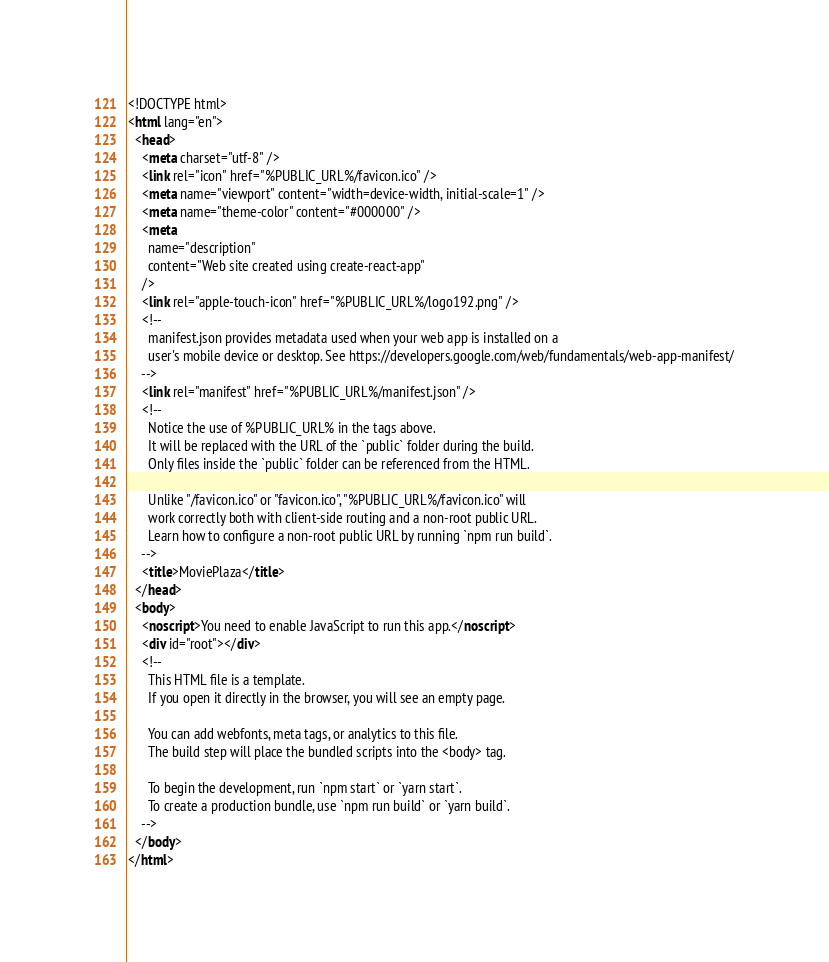<code> <loc_0><loc_0><loc_500><loc_500><_HTML_><!DOCTYPE html>
<html lang="en">
  <head>
    <meta charset="utf-8" />
    <link rel="icon" href="%PUBLIC_URL%/favicon.ico" />
    <meta name="viewport" content="width=device-width, initial-scale=1" />
    <meta name="theme-color" content="#000000" />
    <meta
      name="description"
      content="Web site created using create-react-app"
    />
    <link rel="apple-touch-icon" href="%PUBLIC_URL%/logo192.png" />
    <!--
      manifest.json provides metadata used when your web app is installed on a
      user's mobile device or desktop. See https://developers.google.com/web/fundamentals/web-app-manifest/
    -->
    <link rel="manifest" href="%PUBLIC_URL%/manifest.json" />
    <!--
      Notice the use of %PUBLIC_URL% in the tags above.
      It will be replaced with the URL of the `public` folder during the build.
      Only files inside the `public` folder can be referenced from the HTML.

      Unlike "/favicon.ico" or "favicon.ico", "%PUBLIC_URL%/favicon.ico" will
      work correctly both with client-side routing and a non-root public URL.
      Learn how to configure a non-root public URL by running `npm run build`.
    -->
    <title>MoviePlaza</title>
  </head>
  <body>
    <noscript>You need to enable JavaScript to run this app.</noscript>
    <div id="root"></div>
    <!--
      This HTML file is a template.
      If you open it directly in the browser, you will see an empty page.

      You can add webfonts, meta tags, or analytics to this file.
      The build step will place the bundled scripts into the <body> tag.

      To begin the development, run `npm start` or `yarn start`.
      To create a production bundle, use `npm run build` or `yarn build`.
    -->
  </body>
</html>
</code> 